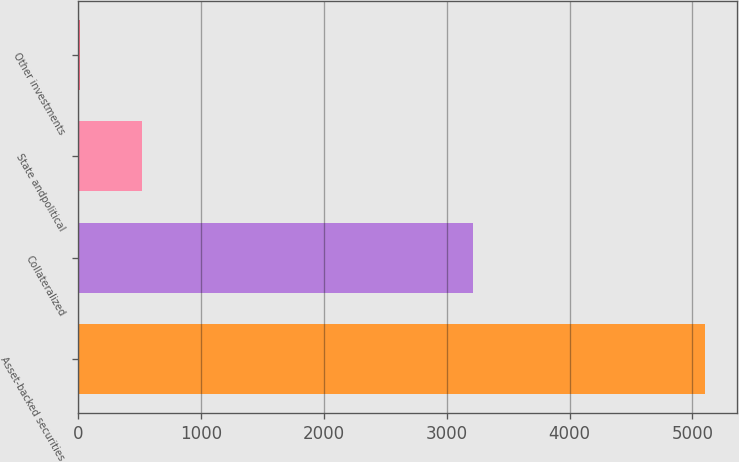Convert chart to OTSL. <chart><loc_0><loc_0><loc_500><loc_500><bar_chart><fcel>Asset-backed securities<fcel>Collateralized<fcel>State andpolitical<fcel>Other investments<nl><fcel>5104<fcel>3211<fcel>523.9<fcel>15<nl></chart> 